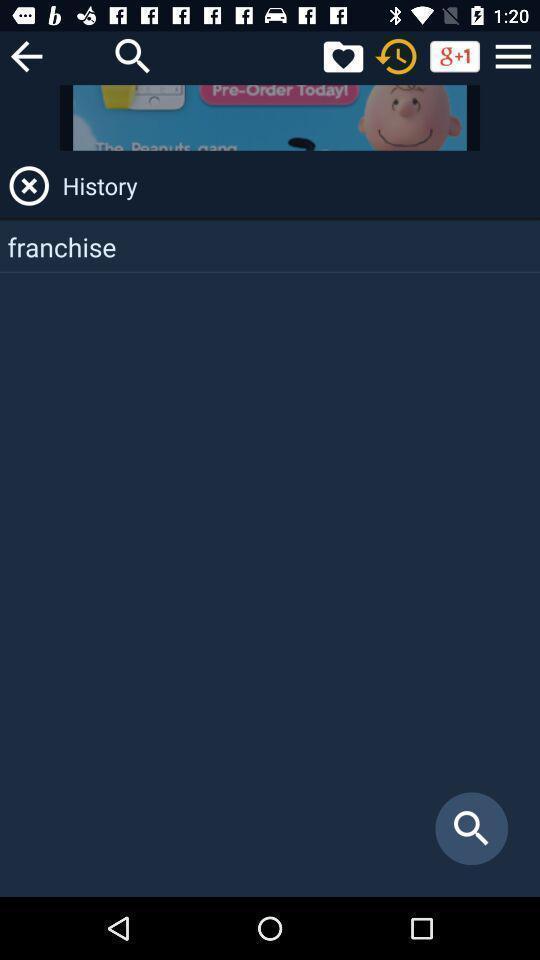Provide a description of this screenshot. Page for the dictionary application. 